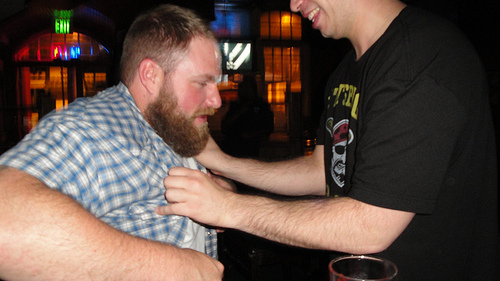<image>
Can you confirm if the man is in front of the man? Yes. The man is positioned in front of the man, appearing closer to the camera viewpoint. 